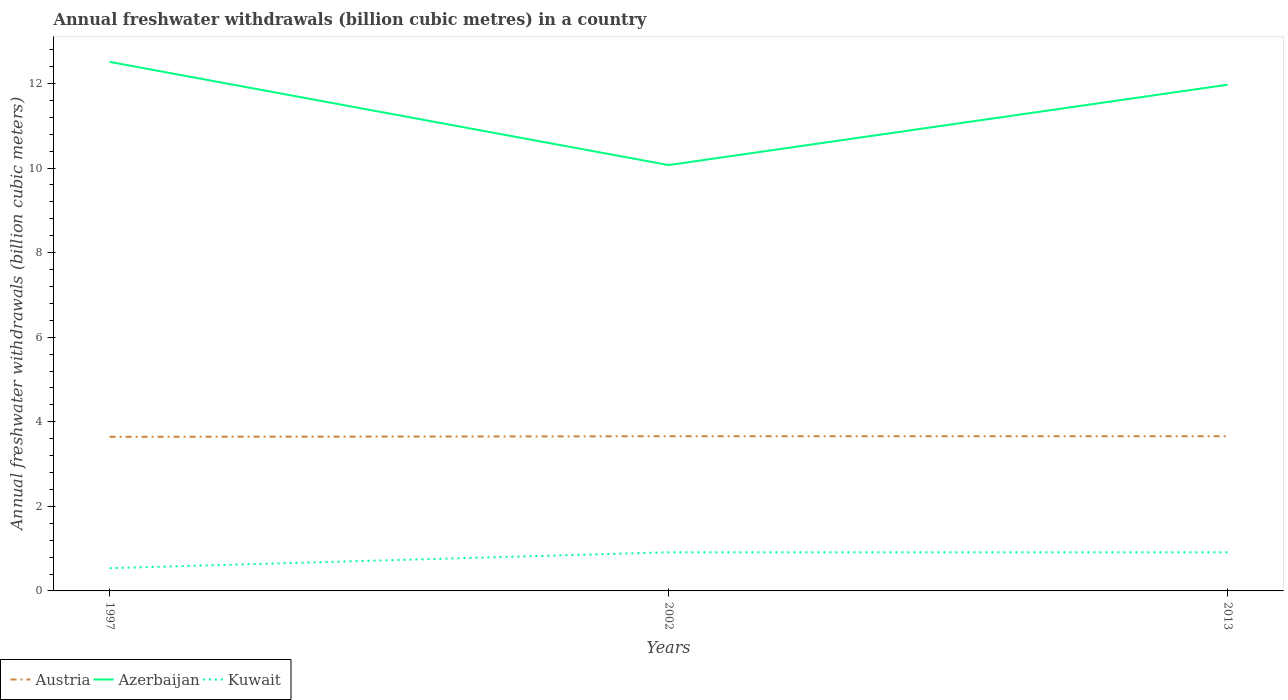How many different coloured lines are there?
Provide a succinct answer. 3. Does the line corresponding to Kuwait intersect with the line corresponding to Azerbaijan?
Make the answer very short. No. Is the number of lines equal to the number of legend labels?
Give a very brief answer. Yes. Across all years, what is the maximum annual freshwater withdrawals in Azerbaijan?
Provide a succinct answer. 10.07. In which year was the annual freshwater withdrawals in Kuwait maximum?
Ensure brevity in your answer.  1997. What is the total annual freshwater withdrawals in Azerbaijan in the graph?
Give a very brief answer. 0.54. What is the difference between the highest and the second highest annual freshwater withdrawals in Azerbaijan?
Provide a short and direct response. 2.44. Is the annual freshwater withdrawals in Kuwait strictly greater than the annual freshwater withdrawals in Azerbaijan over the years?
Provide a short and direct response. Yes. How many years are there in the graph?
Your answer should be very brief. 3. What is the difference between two consecutive major ticks on the Y-axis?
Provide a succinct answer. 2. How many legend labels are there?
Make the answer very short. 3. What is the title of the graph?
Keep it short and to the point. Annual freshwater withdrawals (billion cubic metres) in a country. Does "Madagascar" appear as one of the legend labels in the graph?
Your answer should be compact. No. What is the label or title of the Y-axis?
Your response must be concise. Annual freshwater withdrawals (billion cubic meters). What is the Annual freshwater withdrawals (billion cubic meters) in Austria in 1997?
Your answer should be very brief. 3.64. What is the Annual freshwater withdrawals (billion cubic meters) of Azerbaijan in 1997?
Provide a short and direct response. 12.51. What is the Annual freshwater withdrawals (billion cubic meters) of Kuwait in 1997?
Provide a short and direct response. 0.54. What is the Annual freshwater withdrawals (billion cubic meters) in Austria in 2002?
Provide a short and direct response. 3.66. What is the Annual freshwater withdrawals (billion cubic meters) of Azerbaijan in 2002?
Your answer should be compact. 10.07. What is the Annual freshwater withdrawals (billion cubic meters) in Kuwait in 2002?
Offer a very short reply. 0.91. What is the Annual freshwater withdrawals (billion cubic meters) in Austria in 2013?
Offer a terse response. 3.66. What is the Annual freshwater withdrawals (billion cubic meters) of Azerbaijan in 2013?
Provide a succinct answer. 11.97. What is the Annual freshwater withdrawals (billion cubic meters) in Kuwait in 2013?
Your answer should be compact. 0.91. Across all years, what is the maximum Annual freshwater withdrawals (billion cubic meters) in Austria?
Offer a very short reply. 3.66. Across all years, what is the maximum Annual freshwater withdrawals (billion cubic meters) in Azerbaijan?
Provide a succinct answer. 12.51. Across all years, what is the maximum Annual freshwater withdrawals (billion cubic meters) of Kuwait?
Provide a succinct answer. 0.91. Across all years, what is the minimum Annual freshwater withdrawals (billion cubic meters) of Austria?
Provide a short and direct response. 3.64. Across all years, what is the minimum Annual freshwater withdrawals (billion cubic meters) of Azerbaijan?
Your answer should be very brief. 10.07. Across all years, what is the minimum Annual freshwater withdrawals (billion cubic meters) in Kuwait?
Ensure brevity in your answer.  0.54. What is the total Annual freshwater withdrawals (billion cubic meters) of Austria in the graph?
Your answer should be compact. 10.96. What is the total Annual freshwater withdrawals (billion cubic meters) in Azerbaijan in the graph?
Your answer should be very brief. 34.55. What is the total Annual freshwater withdrawals (billion cubic meters) in Kuwait in the graph?
Offer a very short reply. 2.36. What is the difference between the Annual freshwater withdrawals (billion cubic meters) in Austria in 1997 and that in 2002?
Your response must be concise. -0.01. What is the difference between the Annual freshwater withdrawals (billion cubic meters) of Azerbaijan in 1997 and that in 2002?
Offer a terse response. 2.44. What is the difference between the Annual freshwater withdrawals (billion cubic meters) in Kuwait in 1997 and that in 2002?
Provide a succinct answer. -0.38. What is the difference between the Annual freshwater withdrawals (billion cubic meters) of Austria in 1997 and that in 2013?
Provide a succinct answer. -0.01. What is the difference between the Annual freshwater withdrawals (billion cubic meters) in Azerbaijan in 1997 and that in 2013?
Offer a very short reply. 0.54. What is the difference between the Annual freshwater withdrawals (billion cubic meters) of Kuwait in 1997 and that in 2013?
Your answer should be very brief. -0.38. What is the difference between the Annual freshwater withdrawals (billion cubic meters) in Austria in 2002 and that in 2013?
Your response must be concise. 0. What is the difference between the Annual freshwater withdrawals (billion cubic meters) of Azerbaijan in 2002 and that in 2013?
Offer a very short reply. -1.9. What is the difference between the Annual freshwater withdrawals (billion cubic meters) of Austria in 1997 and the Annual freshwater withdrawals (billion cubic meters) of Azerbaijan in 2002?
Your answer should be very brief. -6.43. What is the difference between the Annual freshwater withdrawals (billion cubic meters) of Austria in 1997 and the Annual freshwater withdrawals (billion cubic meters) of Kuwait in 2002?
Provide a short and direct response. 2.73. What is the difference between the Annual freshwater withdrawals (billion cubic meters) in Azerbaijan in 1997 and the Annual freshwater withdrawals (billion cubic meters) in Kuwait in 2002?
Your answer should be very brief. 11.6. What is the difference between the Annual freshwater withdrawals (billion cubic meters) in Austria in 1997 and the Annual freshwater withdrawals (billion cubic meters) in Azerbaijan in 2013?
Ensure brevity in your answer.  -8.33. What is the difference between the Annual freshwater withdrawals (billion cubic meters) of Austria in 1997 and the Annual freshwater withdrawals (billion cubic meters) of Kuwait in 2013?
Offer a very short reply. 2.73. What is the difference between the Annual freshwater withdrawals (billion cubic meters) of Azerbaijan in 1997 and the Annual freshwater withdrawals (billion cubic meters) of Kuwait in 2013?
Provide a succinct answer. 11.6. What is the difference between the Annual freshwater withdrawals (billion cubic meters) in Austria in 2002 and the Annual freshwater withdrawals (billion cubic meters) in Azerbaijan in 2013?
Keep it short and to the point. -8.31. What is the difference between the Annual freshwater withdrawals (billion cubic meters) of Austria in 2002 and the Annual freshwater withdrawals (billion cubic meters) of Kuwait in 2013?
Offer a terse response. 2.74. What is the difference between the Annual freshwater withdrawals (billion cubic meters) in Azerbaijan in 2002 and the Annual freshwater withdrawals (billion cubic meters) in Kuwait in 2013?
Provide a succinct answer. 9.16. What is the average Annual freshwater withdrawals (billion cubic meters) in Austria per year?
Provide a succinct answer. 3.65. What is the average Annual freshwater withdrawals (billion cubic meters) in Azerbaijan per year?
Offer a terse response. 11.52. What is the average Annual freshwater withdrawals (billion cubic meters) in Kuwait per year?
Your answer should be very brief. 0.79. In the year 1997, what is the difference between the Annual freshwater withdrawals (billion cubic meters) in Austria and Annual freshwater withdrawals (billion cubic meters) in Azerbaijan?
Your answer should be compact. -8.87. In the year 1997, what is the difference between the Annual freshwater withdrawals (billion cubic meters) of Austria and Annual freshwater withdrawals (billion cubic meters) of Kuwait?
Keep it short and to the point. 3.11. In the year 1997, what is the difference between the Annual freshwater withdrawals (billion cubic meters) of Azerbaijan and Annual freshwater withdrawals (billion cubic meters) of Kuwait?
Provide a short and direct response. 11.97. In the year 2002, what is the difference between the Annual freshwater withdrawals (billion cubic meters) in Austria and Annual freshwater withdrawals (billion cubic meters) in Azerbaijan?
Your response must be concise. -6.41. In the year 2002, what is the difference between the Annual freshwater withdrawals (billion cubic meters) in Austria and Annual freshwater withdrawals (billion cubic meters) in Kuwait?
Ensure brevity in your answer.  2.74. In the year 2002, what is the difference between the Annual freshwater withdrawals (billion cubic meters) in Azerbaijan and Annual freshwater withdrawals (billion cubic meters) in Kuwait?
Offer a terse response. 9.16. In the year 2013, what is the difference between the Annual freshwater withdrawals (billion cubic meters) in Austria and Annual freshwater withdrawals (billion cubic meters) in Azerbaijan?
Provide a succinct answer. -8.31. In the year 2013, what is the difference between the Annual freshwater withdrawals (billion cubic meters) in Austria and Annual freshwater withdrawals (billion cubic meters) in Kuwait?
Ensure brevity in your answer.  2.74. In the year 2013, what is the difference between the Annual freshwater withdrawals (billion cubic meters) of Azerbaijan and Annual freshwater withdrawals (billion cubic meters) of Kuwait?
Give a very brief answer. 11.06. What is the ratio of the Annual freshwater withdrawals (billion cubic meters) of Austria in 1997 to that in 2002?
Provide a succinct answer. 1. What is the ratio of the Annual freshwater withdrawals (billion cubic meters) in Azerbaijan in 1997 to that in 2002?
Your answer should be compact. 1.24. What is the ratio of the Annual freshwater withdrawals (billion cubic meters) of Kuwait in 1997 to that in 2002?
Offer a terse response. 0.59. What is the ratio of the Annual freshwater withdrawals (billion cubic meters) in Azerbaijan in 1997 to that in 2013?
Your response must be concise. 1.05. What is the ratio of the Annual freshwater withdrawals (billion cubic meters) of Kuwait in 1997 to that in 2013?
Offer a terse response. 0.59. What is the ratio of the Annual freshwater withdrawals (billion cubic meters) of Austria in 2002 to that in 2013?
Ensure brevity in your answer.  1. What is the ratio of the Annual freshwater withdrawals (billion cubic meters) in Azerbaijan in 2002 to that in 2013?
Provide a succinct answer. 0.84. What is the difference between the highest and the second highest Annual freshwater withdrawals (billion cubic meters) of Austria?
Your answer should be very brief. 0. What is the difference between the highest and the second highest Annual freshwater withdrawals (billion cubic meters) in Azerbaijan?
Offer a terse response. 0.54. What is the difference between the highest and the lowest Annual freshwater withdrawals (billion cubic meters) in Austria?
Your answer should be compact. 0.01. What is the difference between the highest and the lowest Annual freshwater withdrawals (billion cubic meters) in Azerbaijan?
Provide a short and direct response. 2.44. What is the difference between the highest and the lowest Annual freshwater withdrawals (billion cubic meters) in Kuwait?
Give a very brief answer. 0.38. 